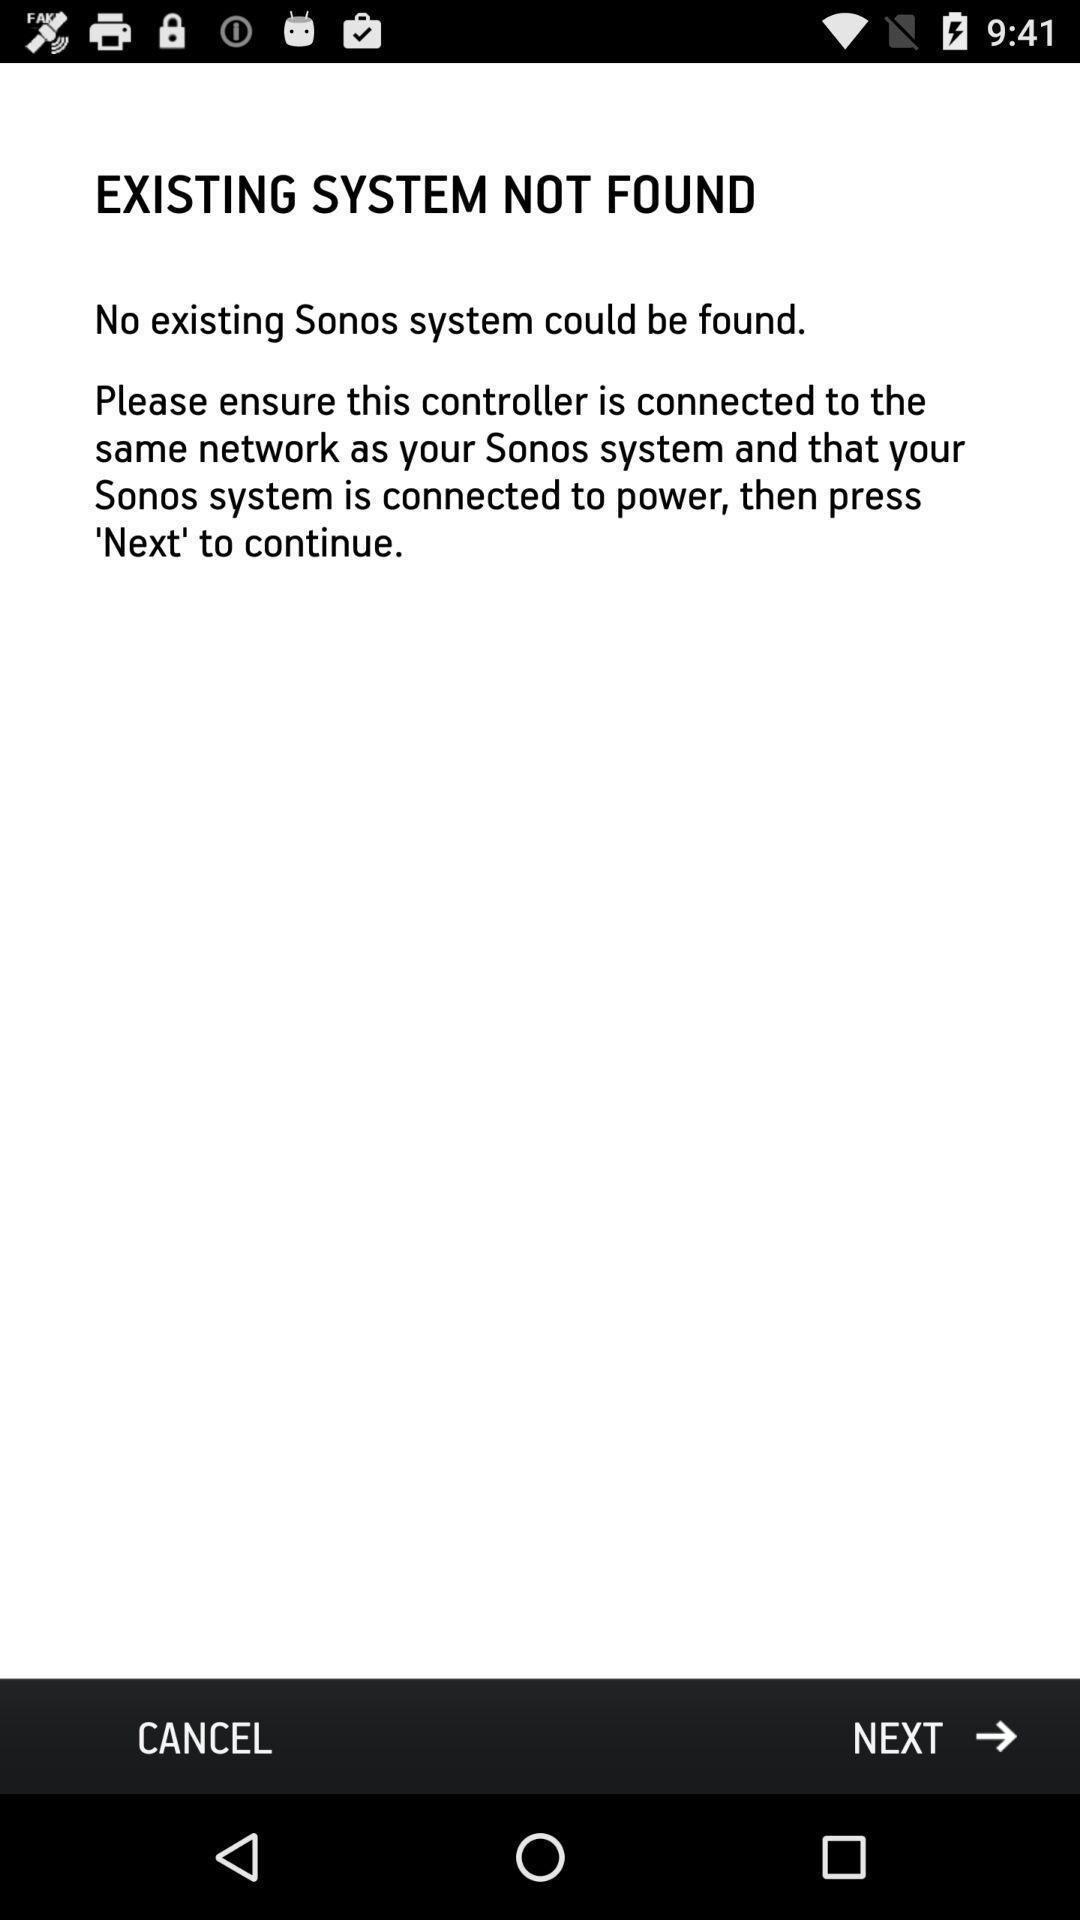Tell me about the visual elements in this screen capture. Screen displaying the guiding options. 